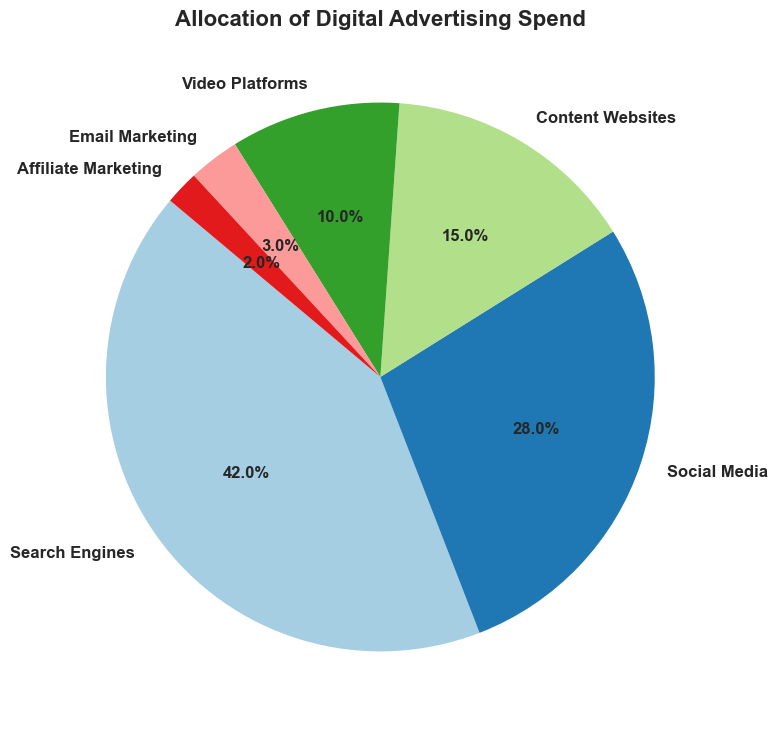What percentage of the advertising spend is allocated to Search Engines? Locate the segment labeled "Search Engines" in the pie chart and refer to the percentage indicated within it.
Answer: 42% Which platform has the least allocation of digital advertising spend? Find the smallest segment in the pie chart and look for the label within it, which will indicate the platform.
Answer: Affiliate Marketing If you combine the spending on Social Media and Content Websites, what percentage do they make up together? Find the percentages for Social Media (28%) and Content Websites (15%) in the pie chart and add them together: 28% + 15% = 43%.
Answer: 43% Which category gets more advertising spend: Content Websites or Video Platforms? Compare the segments labeled "Content Websites" and "Video Platforms" in the pie chart. Note their percentages: Content Websites (15%) and Video Platforms (10%).
Answer: Content Websites How much more is spent on Search Engines compared to Social Media? Note the percentages for Search Engines (42%) and Social Media (28%). Subtract the smaller percentage from the larger one: 42% - 28% = 14%.
Answer: 14% What is the combined percentage of advertising spend on Email Marketing and Affiliate Marketing? Find the percentages for Email Marketing (3%) and Affiliate Marketing (2%) in the pie chart and add them together: 3% + 2% = 5%.
Answer: 5% Which platform's allocation, when doubled, would equal the allocation of Social Media? Look for a segment where doubling the percentage will give you 28% (the percentage for Social Media). This would be Content Websites, which has 15%. Doubling 15% is 30%, which is closest to Social Media's 28%.
Answer: Content Websites What percentage of the advertising spend is allocated to platforms other than Search Engines and Social Media? Subtract the percentages for Search Engines (42%) and Social Media (28%) from 100%: 100% - 42% - 28% = 30%.
Answer: 30% If each dollar spent on Email Marketing was reallocated to Video Platforms, what would be the new percentage allocated to Video Platforms? Add the percentage of Email Marketing (3%) to Video Platforms (10%): 10% + 3% = 13%.
Answer: 13% How many platforms have an allocation of less than 10%? Identify the segments with percentages less than 10%: Email Marketing (3%) and Affiliate Marketing (2%). Count these segments.
Answer: 2 